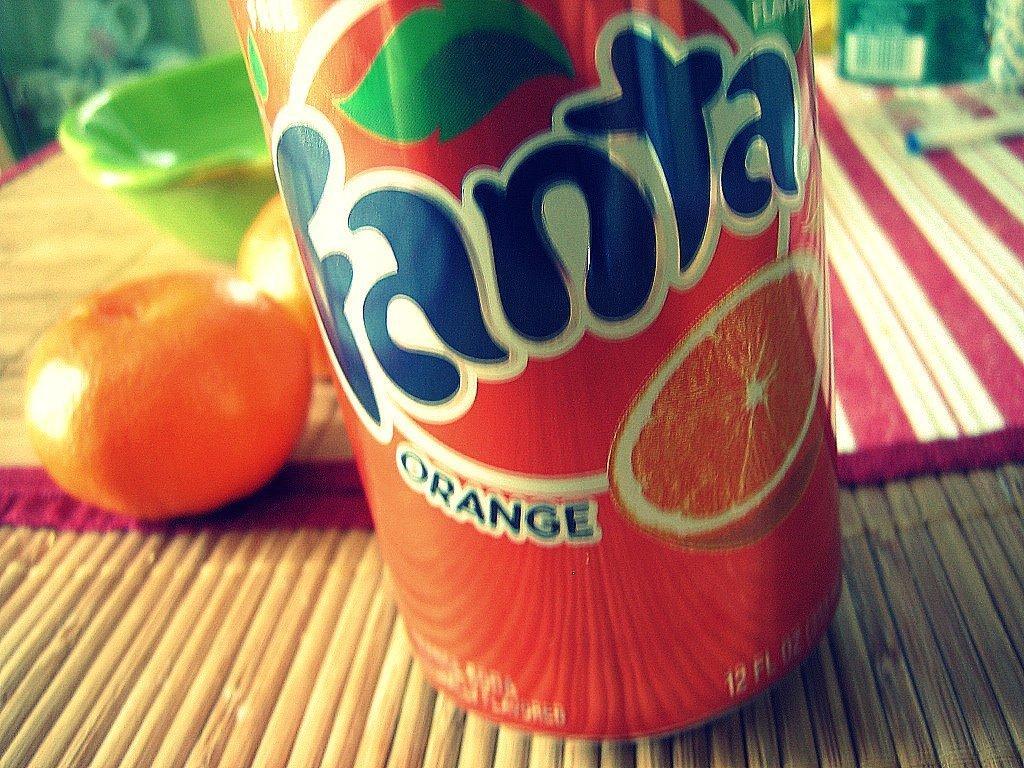Can you describe this image briefly? In the image there is some drink, an orange and other items. 